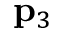<formula> <loc_0><loc_0><loc_500><loc_500>{ p } _ { 3 }</formula> 